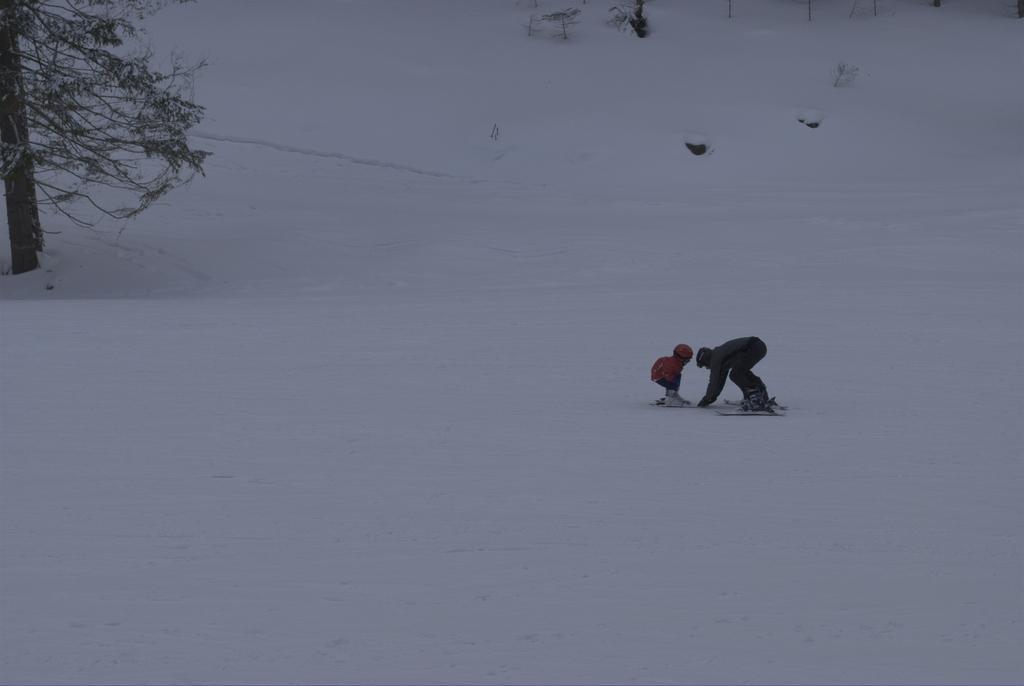Could you give a brief overview of what you see in this image? This picture is clicked outside. On the right we can see the two persons seems to be standing on the ski-boards and we can see there is a lot of snow and we can see a tree and some other objects. 